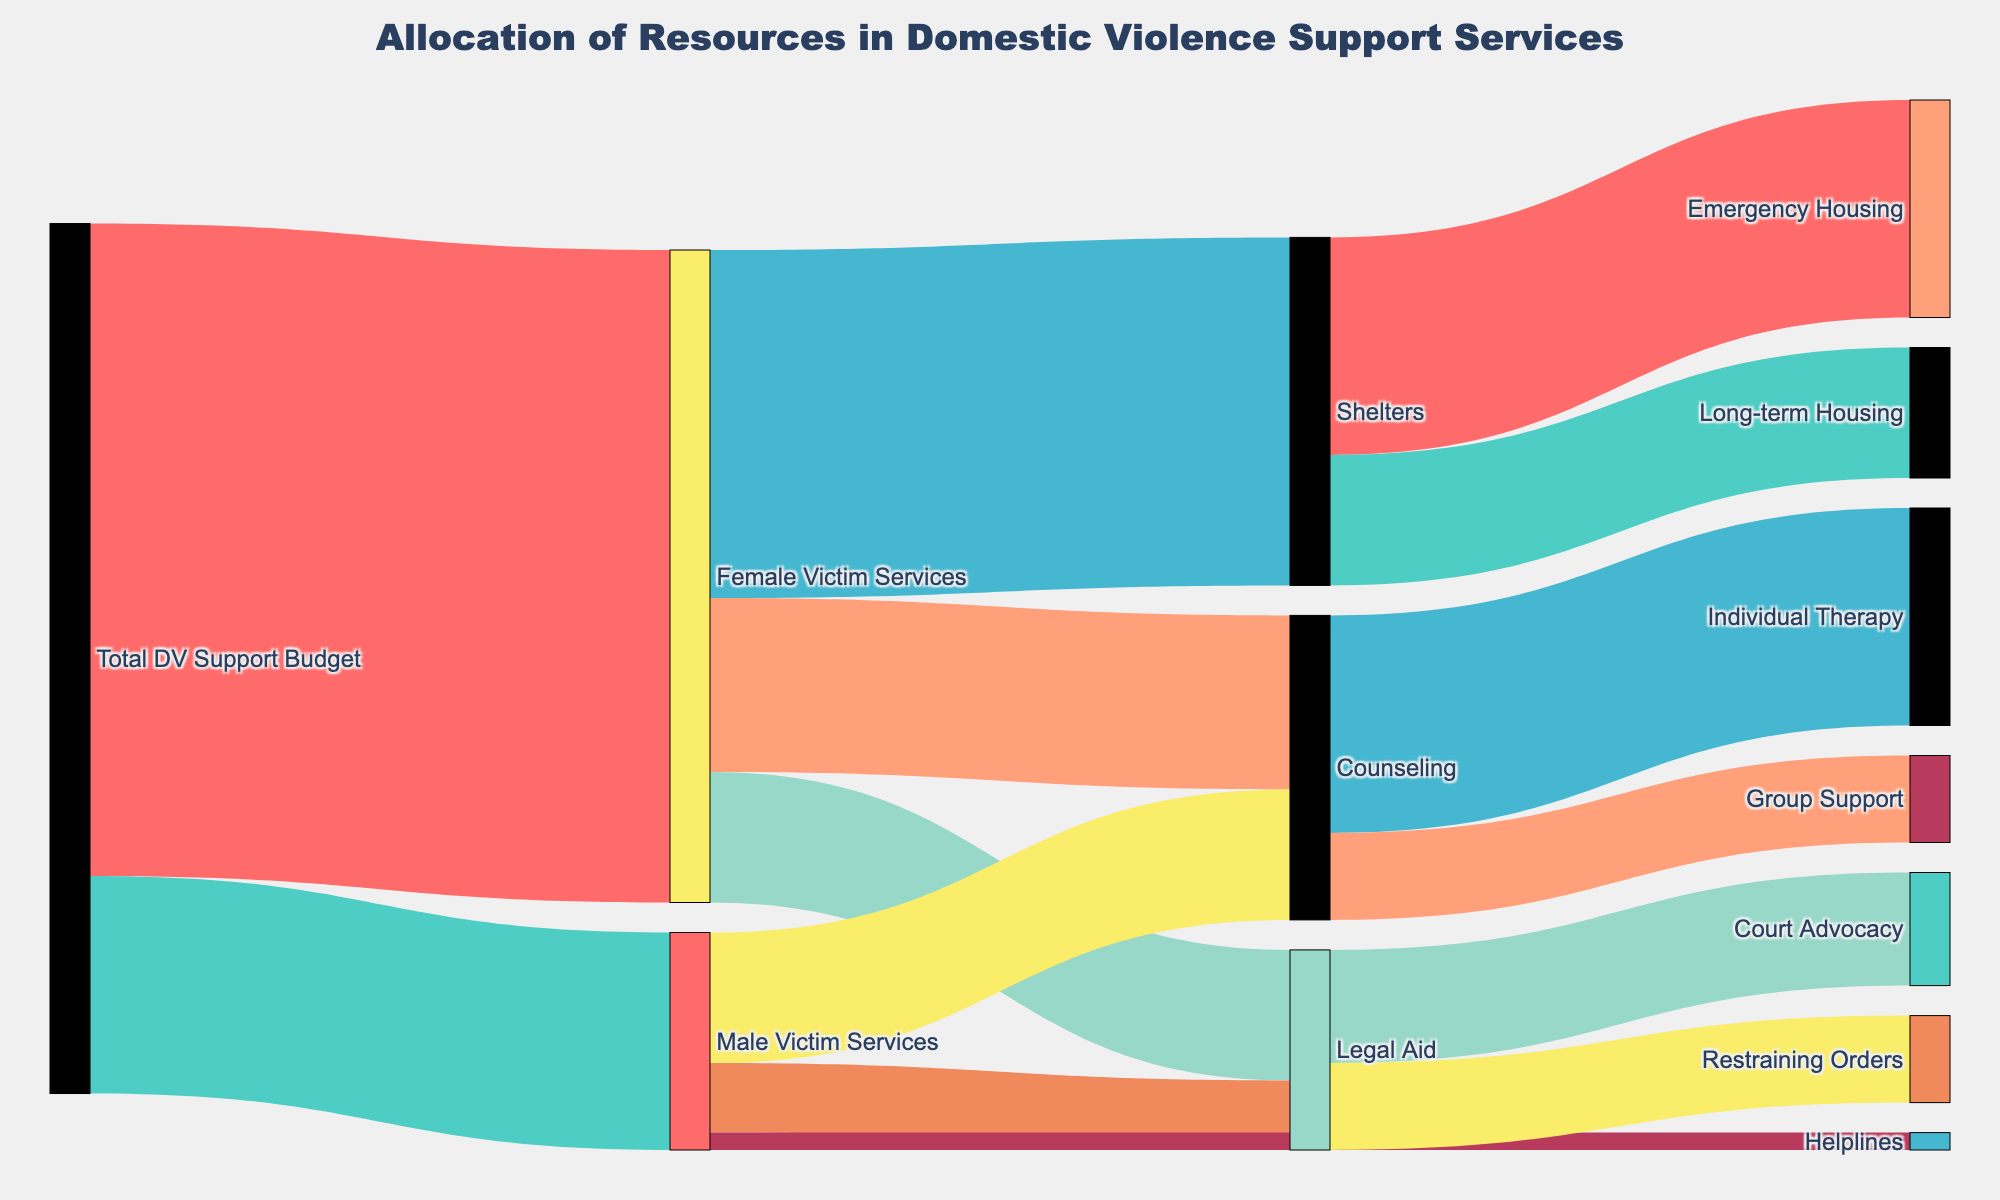How much of the total DV support budget is allocated to female victim services? The figure shows that the total DV support budget is divided into female and male victim services. The portion allocated to female victim services is labeled directly.
Answer: 75 How many resources are dedicated to helplines for male victims? According to the diagram, male victim services are broken down into counseling, legal aid, and helplines. The resources for helplines are indicated.
Answer: 2 What's the total amount of resources assigned to counseling for both male and female victims? The figure lists counseling resources under both male and female victim services. Adding the values for both categories: 20 (female) + 15 (male) = 35.
Answer: 35 Which specific service under female victim services receives the highest allocation? The segments within female victim services are emergency shelters, legal aid, and counseling. The highest valued segment is identified.
Answer: Shelters How does the allocation for long-term housing compare to emergency housing under shelters? The Sankey diagram splits shelters into emergency housing and long-term housing. By comparing their values, emergency housing has 25, and long-term housing has 15.
Answer: Emergency housing has more What percentage of the total budget is allocated to legal aid services for male victims? The total DV support budget for male victims is 25. Out of this, legal aid is 8. Therefore, (8/25) * 100 = 32%.
Answer: 32% What type of resource distribution does the Sankey diagram show between counseling and legal aid under female victim services? Counseling under female victim services has an allocation of 20, while legal aid has 15. Comparing the two, counseling has a higher allocation.
Answer: Counseling has more How much more is allocated to individual therapy compared to group support under counseling? Counseling splits into individual therapy and group support. Individual therapy receives 25, and group support receives 10. The difference is 25 - 10.
Answer: 15 What is the total allocation from the shelters category? Shelters are divided into emergency housing and long-term housing. Adding these values: 25 (emergency housing) + 15 (long-term housing) = 40.
Answer: 40 How does the budget for restraining orders compare to court advocacy under legal aid? Legal aid's allocations for court advocacy and restraining orders are compared. Court advocacy has 13, and restraining orders have 10.
Answer: Court advocacy has more 